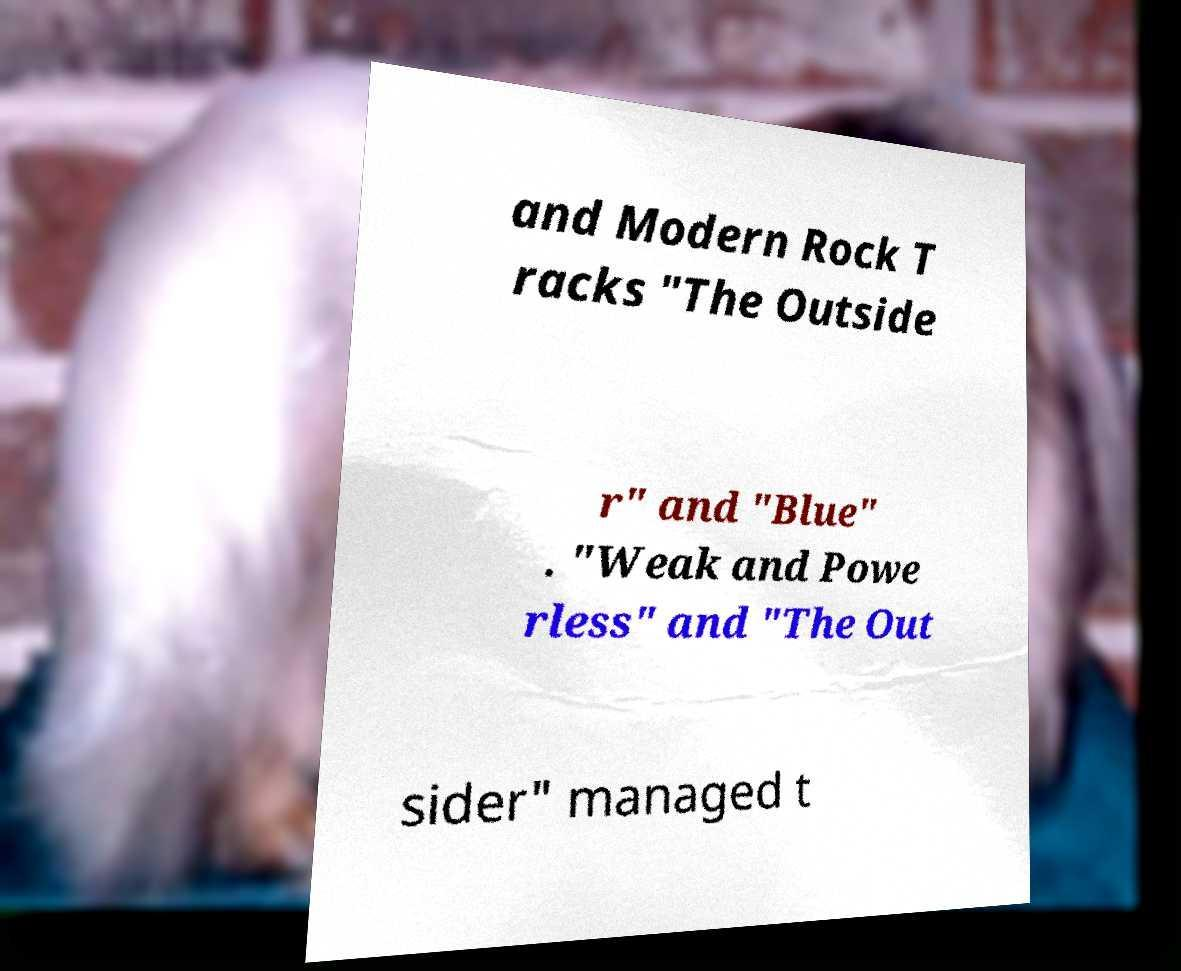Can you read and provide the text displayed in the image?This photo seems to have some interesting text. Can you extract and type it out for me? and Modern Rock T racks "The Outside r" and "Blue" . "Weak and Powe rless" and "The Out sider" managed t 